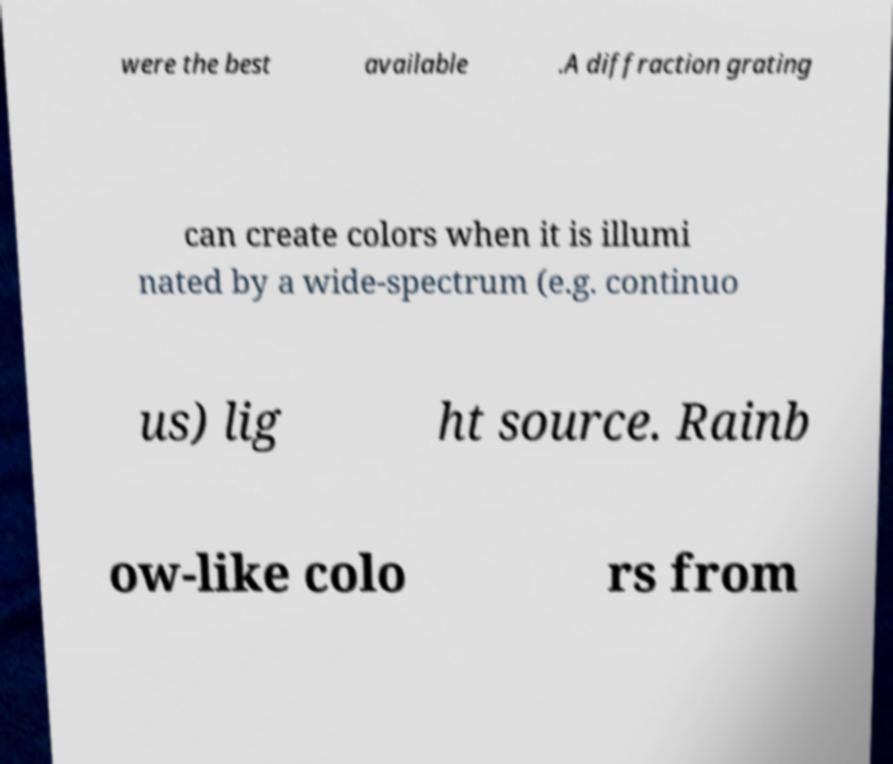What messages or text are displayed in this image? I need them in a readable, typed format. were the best available .A diffraction grating can create colors when it is illumi nated by a wide-spectrum (e.g. continuo us) lig ht source. Rainb ow-like colo rs from 